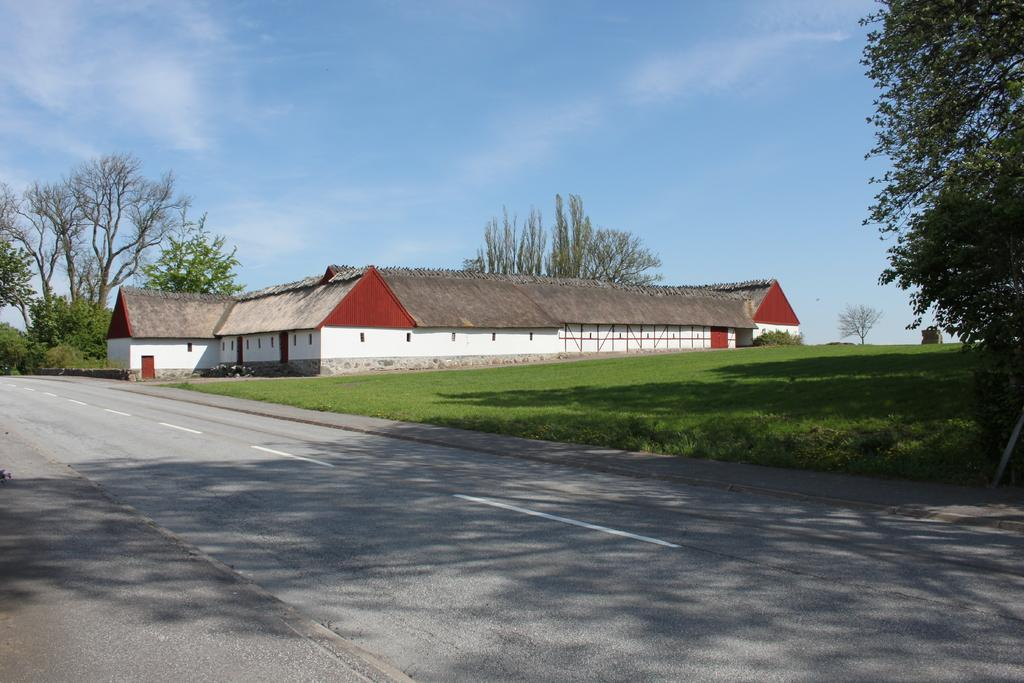What color is the sky in the image? The sky is blue in the image. What type of vegetation is visible in the image? There is grass visible in the image. What type of structure can be seen in the image? There is a house with windows in the image. What else can be seen in the sky in the image? There are clouds in the image. What other type of vegetation can be seen in the image? There are trees in the image. How does the flock of birds fly in the image? There are no birds visible in the image, so it is not possible to answer that question. 